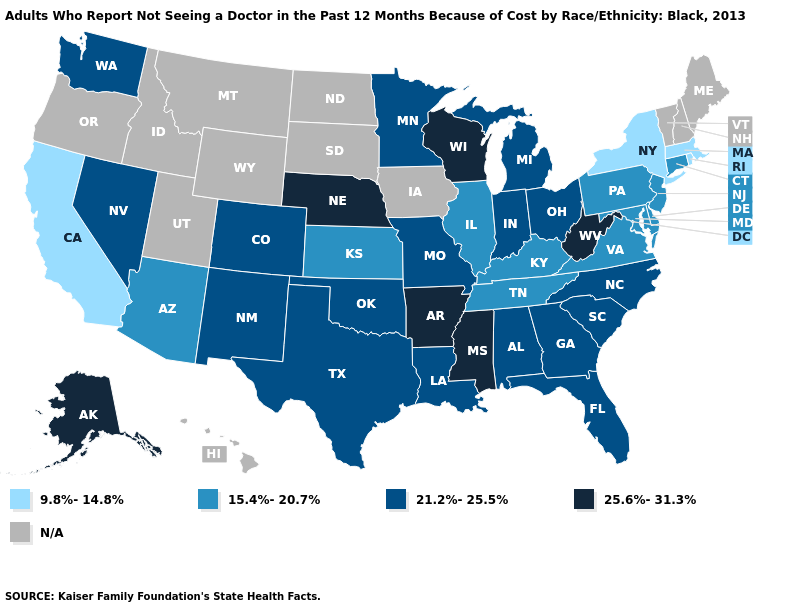What is the value of North Carolina?
Concise answer only. 21.2%-25.5%. What is the highest value in the West ?
Concise answer only. 25.6%-31.3%. Name the states that have a value in the range 9.8%-14.8%?
Keep it brief. California, Massachusetts, New York, Rhode Island. What is the highest value in the USA?
Answer briefly. 25.6%-31.3%. Name the states that have a value in the range 21.2%-25.5%?
Be succinct. Alabama, Colorado, Florida, Georgia, Indiana, Louisiana, Michigan, Minnesota, Missouri, Nevada, New Mexico, North Carolina, Ohio, Oklahoma, South Carolina, Texas, Washington. Name the states that have a value in the range 15.4%-20.7%?
Give a very brief answer. Arizona, Connecticut, Delaware, Illinois, Kansas, Kentucky, Maryland, New Jersey, Pennsylvania, Tennessee, Virginia. Name the states that have a value in the range 21.2%-25.5%?
Concise answer only. Alabama, Colorado, Florida, Georgia, Indiana, Louisiana, Michigan, Minnesota, Missouri, Nevada, New Mexico, North Carolina, Ohio, Oklahoma, South Carolina, Texas, Washington. Among the states that border Rhode Island , which have the highest value?
Give a very brief answer. Connecticut. Does Virginia have the highest value in the South?
Be succinct. No. What is the lowest value in the USA?
Write a very short answer. 9.8%-14.8%. Name the states that have a value in the range 25.6%-31.3%?
Concise answer only. Alaska, Arkansas, Mississippi, Nebraska, West Virginia, Wisconsin. What is the value of Alaska?
Give a very brief answer. 25.6%-31.3%. Does Alaska have the lowest value in the West?
Short answer required. No. What is the highest value in states that border Florida?
Keep it brief. 21.2%-25.5%. 